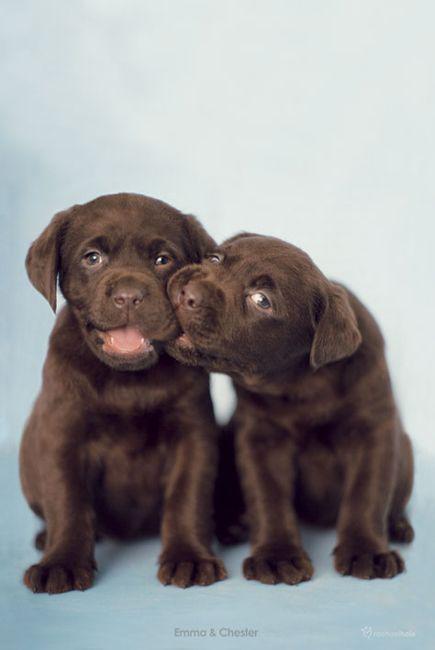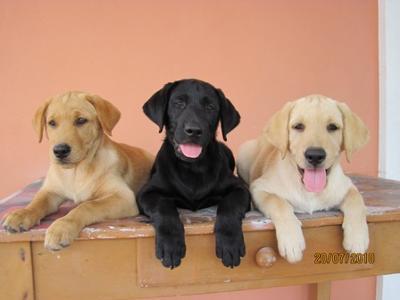The first image is the image on the left, the second image is the image on the right. Given the left and right images, does the statement "There are a total of 2 adult Labradors interacting with each other." hold true? Answer yes or no. No. The first image is the image on the left, the second image is the image on the right. For the images shown, is this caption "There are three dogs in one picture and two in the other picture." true? Answer yes or no. Yes. 